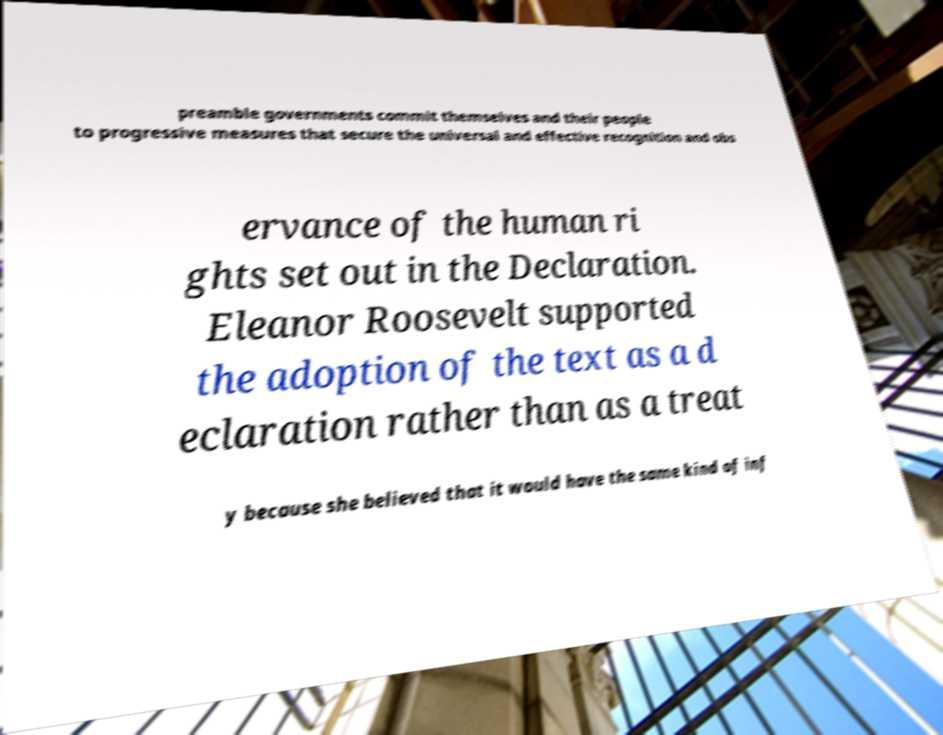Can you accurately transcribe the text from the provided image for me? preamble governments commit themselves and their people to progressive measures that secure the universal and effective recognition and obs ervance of the human ri ghts set out in the Declaration. Eleanor Roosevelt supported the adoption of the text as a d eclaration rather than as a treat y because she believed that it would have the same kind of inf 